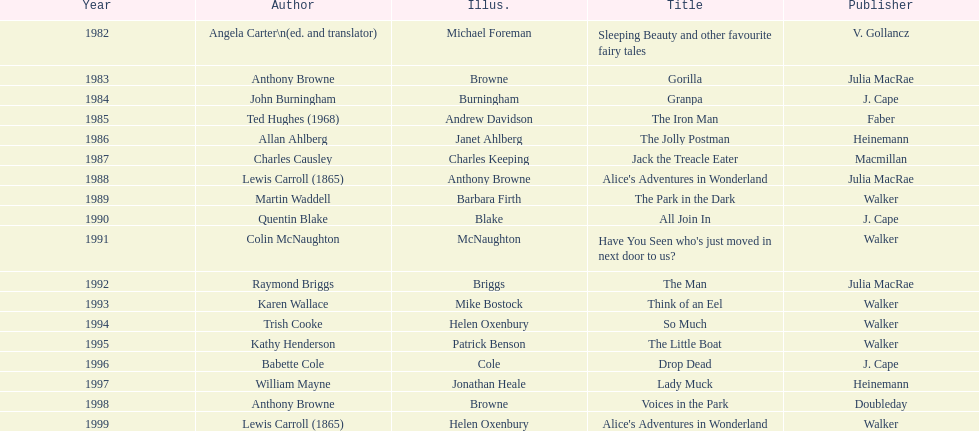Which author wrote the first award winner? Angela Carter. Give me the full table as a dictionary. {'header': ['Year', 'Author', 'Illus.', 'Title', 'Publisher'], 'rows': [['1982', 'Angela Carter\\n(ed. and translator)', 'Michael Foreman', 'Sleeping Beauty and other favourite fairy tales', 'V. Gollancz'], ['1983', 'Anthony Browne', 'Browne', 'Gorilla', 'Julia MacRae'], ['1984', 'John Burningham', 'Burningham', 'Granpa', 'J. Cape'], ['1985', 'Ted Hughes (1968)', 'Andrew Davidson', 'The Iron Man', 'Faber'], ['1986', 'Allan Ahlberg', 'Janet Ahlberg', 'The Jolly Postman', 'Heinemann'], ['1987', 'Charles Causley', 'Charles Keeping', 'Jack the Treacle Eater', 'Macmillan'], ['1988', 'Lewis Carroll (1865)', 'Anthony Browne', "Alice's Adventures in Wonderland", 'Julia MacRae'], ['1989', 'Martin Waddell', 'Barbara Firth', 'The Park in the Dark', 'Walker'], ['1990', 'Quentin Blake', 'Blake', 'All Join In', 'J. Cape'], ['1991', 'Colin McNaughton', 'McNaughton', "Have You Seen who's just moved in next door to us?", 'Walker'], ['1992', 'Raymond Briggs', 'Briggs', 'The Man', 'Julia MacRae'], ['1993', 'Karen Wallace', 'Mike Bostock', 'Think of an Eel', 'Walker'], ['1994', 'Trish Cooke', 'Helen Oxenbury', 'So Much', 'Walker'], ['1995', 'Kathy Henderson', 'Patrick Benson', 'The Little Boat', 'Walker'], ['1996', 'Babette Cole', 'Cole', 'Drop Dead', 'J. Cape'], ['1997', 'William Mayne', 'Jonathan Heale', 'Lady Muck', 'Heinemann'], ['1998', 'Anthony Browne', 'Browne', 'Voices in the Park', 'Doubleday'], ['1999', 'Lewis Carroll (1865)', 'Helen Oxenbury', "Alice's Adventures in Wonderland", 'Walker']]} 